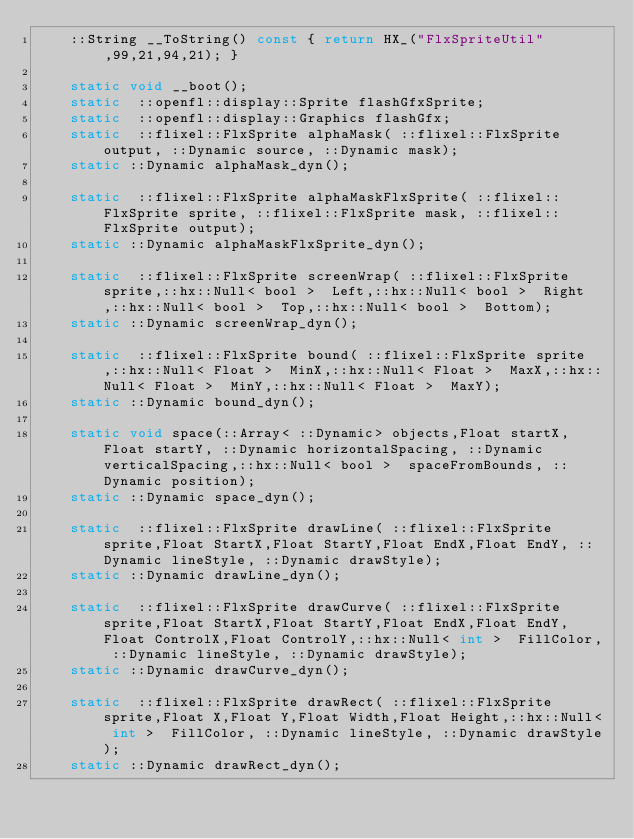Convert code to text. <code><loc_0><loc_0><loc_500><loc_500><_C_>		::String __ToString() const { return HX_("FlxSpriteUtil",99,21,94,21); }

		static void __boot();
		static  ::openfl::display::Sprite flashGfxSprite;
		static  ::openfl::display::Graphics flashGfx;
		static  ::flixel::FlxSprite alphaMask( ::flixel::FlxSprite output, ::Dynamic source, ::Dynamic mask);
		static ::Dynamic alphaMask_dyn();

		static  ::flixel::FlxSprite alphaMaskFlxSprite( ::flixel::FlxSprite sprite, ::flixel::FlxSprite mask, ::flixel::FlxSprite output);
		static ::Dynamic alphaMaskFlxSprite_dyn();

		static  ::flixel::FlxSprite screenWrap( ::flixel::FlxSprite sprite,::hx::Null< bool >  Left,::hx::Null< bool >  Right,::hx::Null< bool >  Top,::hx::Null< bool >  Bottom);
		static ::Dynamic screenWrap_dyn();

		static  ::flixel::FlxSprite bound( ::flixel::FlxSprite sprite,::hx::Null< Float >  MinX,::hx::Null< Float >  MaxX,::hx::Null< Float >  MinY,::hx::Null< Float >  MaxY);
		static ::Dynamic bound_dyn();

		static void space(::Array< ::Dynamic> objects,Float startX,Float startY, ::Dynamic horizontalSpacing, ::Dynamic verticalSpacing,::hx::Null< bool >  spaceFromBounds, ::Dynamic position);
		static ::Dynamic space_dyn();

		static  ::flixel::FlxSprite drawLine( ::flixel::FlxSprite sprite,Float StartX,Float StartY,Float EndX,Float EndY, ::Dynamic lineStyle, ::Dynamic drawStyle);
		static ::Dynamic drawLine_dyn();

		static  ::flixel::FlxSprite drawCurve( ::flixel::FlxSprite sprite,Float StartX,Float StartY,Float EndX,Float EndY,Float ControlX,Float ControlY,::hx::Null< int >  FillColor, ::Dynamic lineStyle, ::Dynamic drawStyle);
		static ::Dynamic drawCurve_dyn();

		static  ::flixel::FlxSprite drawRect( ::flixel::FlxSprite sprite,Float X,Float Y,Float Width,Float Height,::hx::Null< int >  FillColor, ::Dynamic lineStyle, ::Dynamic drawStyle);
		static ::Dynamic drawRect_dyn();
</code> 